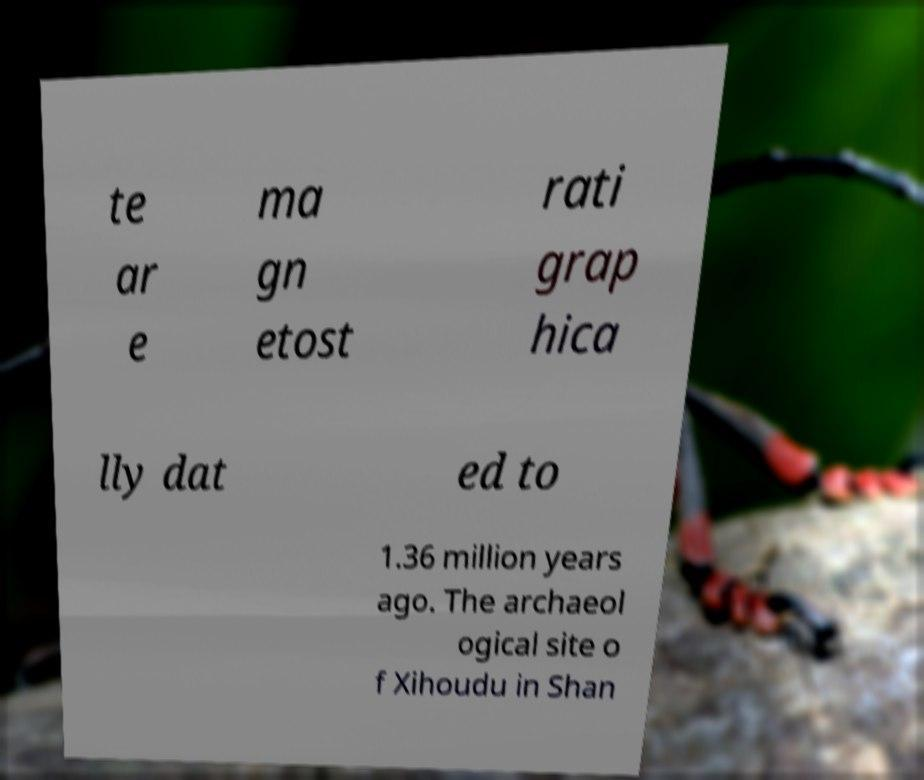What messages or text are displayed in this image? I need them in a readable, typed format. te ar e ma gn etost rati grap hica lly dat ed to 1.36 million years ago. The archaeol ogical site o f Xihoudu in Shan 